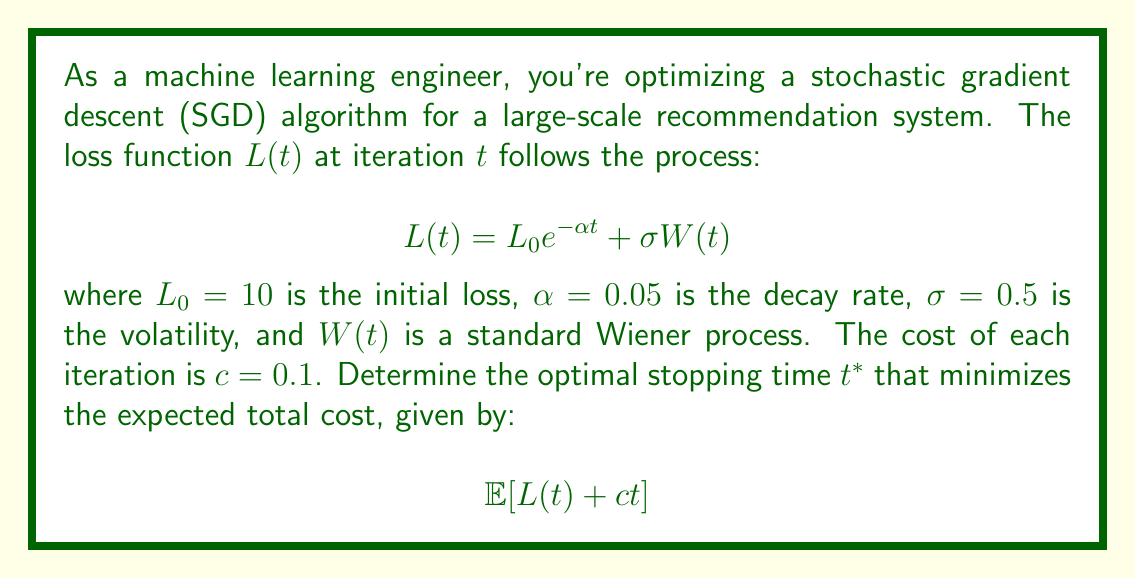Show me your answer to this math problem. To solve this problem, we'll use the optimal stopping theory for continuous-time processes. The steps are as follows:

1) The expected value of the loss function at time $t$ is:
   $$\mathbb{E}[L(t)] = L_0 e^{-\alpha t} + \mathbb{E}[\sigma W(t)] = L_0 e^{-\alpha t}$$
   This is because $\mathbb{E}[W(t)] = 0$ for a Wiener process.

2) The expected total cost function is:
   $$V(t) = \mathbb{E}[L(t) + ct] = L_0 e^{-\alpha t} + ct$$

3) To find the optimal stopping time, we differentiate $V(t)$ with respect to $t$ and set it to zero:
   $$\frac{dV}{dt} = -\alpha L_0 e^{-\alpha t} + c = 0$$

4) Solving for $t$:
   $$\alpha L_0 e^{-\alpha t} = c$$
   $$e^{-\alpha t} = \frac{c}{\alpha L_0}$$
   $$-\alpha t = \ln(\frac{c}{\alpha L_0})$$
   $$t^* = -\frac{1}{\alpha} \ln(\frac{c}{\alpha L_0})$$

5) Substituting the given values:
   $$t^* = -\frac{1}{0.05} \ln(\frac{0.1}{0.05 \cdot 10}) = 20 \ln(2) \approx 13.86$$

The optimal stopping time is approximately 13.86 iterations.

6) To verify this is a minimum, we can check the second derivative:
   $$\frac{d^2V}{dt^2} = \alpha^2 L_0 e^{-\alpha t} > 0$$
   This is always positive, confirming that we've found a minimum.
Answer: $t^* = 20 \ln(2) \approx 13.86$ iterations 